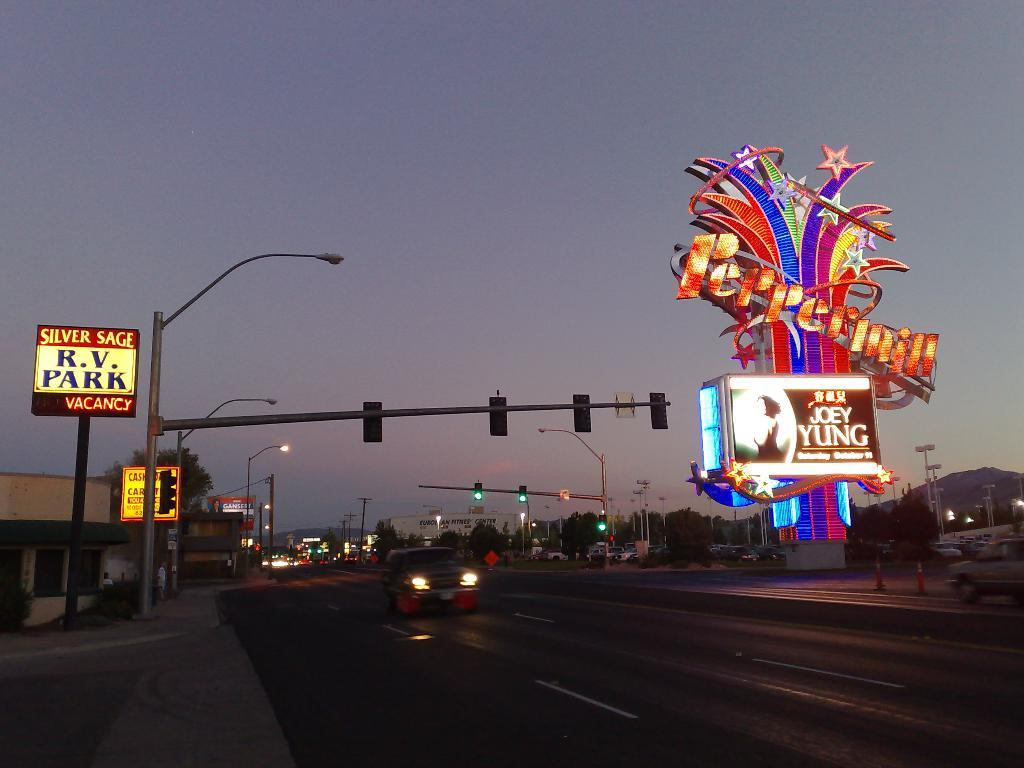<image>
Summarize the visual content of the image. a street with a very colorful building called Peppermill 